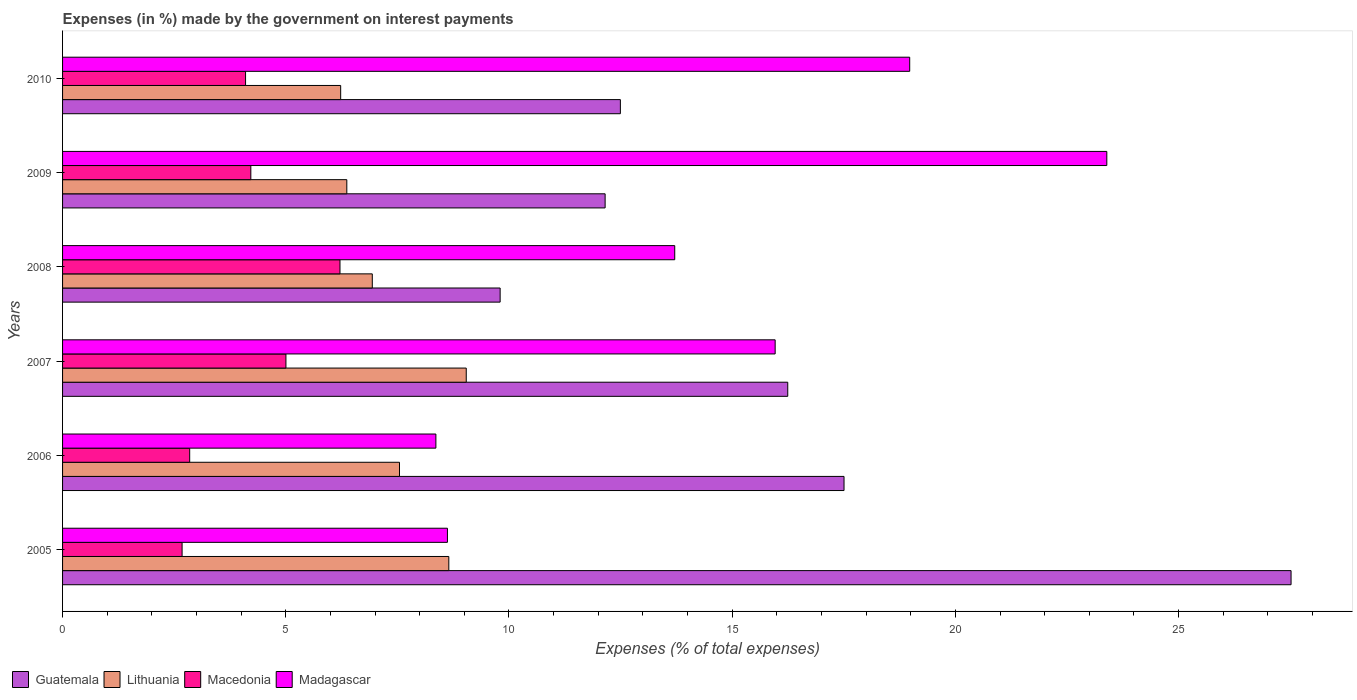How many different coloured bars are there?
Your answer should be compact. 4. How many groups of bars are there?
Provide a short and direct response. 6. How many bars are there on the 2nd tick from the bottom?
Provide a short and direct response. 4. What is the label of the 6th group of bars from the top?
Provide a short and direct response. 2005. What is the percentage of expenses made by the government on interest payments in Macedonia in 2005?
Give a very brief answer. 2.68. Across all years, what is the maximum percentage of expenses made by the government on interest payments in Guatemala?
Your answer should be very brief. 27.52. Across all years, what is the minimum percentage of expenses made by the government on interest payments in Macedonia?
Ensure brevity in your answer.  2.68. What is the total percentage of expenses made by the government on interest payments in Macedonia in the graph?
Your answer should be compact. 25.06. What is the difference between the percentage of expenses made by the government on interest payments in Lithuania in 2005 and that in 2009?
Provide a short and direct response. 2.28. What is the difference between the percentage of expenses made by the government on interest payments in Madagascar in 2010 and the percentage of expenses made by the government on interest payments in Lithuania in 2006?
Your answer should be compact. 11.43. What is the average percentage of expenses made by the government on interest payments in Lithuania per year?
Make the answer very short. 7.46. In the year 2006, what is the difference between the percentage of expenses made by the government on interest payments in Madagascar and percentage of expenses made by the government on interest payments in Lithuania?
Provide a succinct answer. 0.81. What is the ratio of the percentage of expenses made by the government on interest payments in Madagascar in 2007 to that in 2008?
Give a very brief answer. 1.16. What is the difference between the highest and the second highest percentage of expenses made by the government on interest payments in Guatemala?
Give a very brief answer. 10.01. What is the difference between the highest and the lowest percentage of expenses made by the government on interest payments in Madagascar?
Your answer should be compact. 15.03. In how many years, is the percentage of expenses made by the government on interest payments in Lithuania greater than the average percentage of expenses made by the government on interest payments in Lithuania taken over all years?
Make the answer very short. 3. What does the 1st bar from the top in 2009 represents?
Your answer should be compact. Madagascar. What does the 3rd bar from the bottom in 2009 represents?
Provide a short and direct response. Macedonia. Are all the bars in the graph horizontal?
Offer a very short reply. Yes. What is the difference between two consecutive major ticks on the X-axis?
Provide a short and direct response. 5. Are the values on the major ticks of X-axis written in scientific E-notation?
Offer a very short reply. No. Does the graph contain any zero values?
Give a very brief answer. No. How many legend labels are there?
Ensure brevity in your answer.  4. What is the title of the graph?
Offer a terse response. Expenses (in %) made by the government on interest payments. What is the label or title of the X-axis?
Offer a terse response. Expenses (% of total expenses). What is the Expenses (% of total expenses) in Guatemala in 2005?
Provide a succinct answer. 27.52. What is the Expenses (% of total expenses) of Lithuania in 2005?
Provide a succinct answer. 8.65. What is the Expenses (% of total expenses) of Macedonia in 2005?
Keep it short and to the point. 2.68. What is the Expenses (% of total expenses) of Madagascar in 2005?
Your answer should be compact. 8.62. What is the Expenses (% of total expenses) of Guatemala in 2006?
Your answer should be very brief. 17.51. What is the Expenses (% of total expenses) of Lithuania in 2006?
Ensure brevity in your answer.  7.55. What is the Expenses (% of total expenses) of Macedonia in 2006?
Offer a very short reply. 2.85. What is the Expenses (% of total expenses) in Madagascar in 2006?
Keep it short and to the point. 8.36. What is the Expenses (% of total expenses) in Guatemala in 2007?
Provide a succinct answer. 16.24. What is the Expenses (% of total expenses) of Lithuania in 2007?
Keep it short and to the point. 9.04. What is the Expenses (% of total expenses) of Macedonia in 2007?
Keep it short and to the point. 5. What is the Expenses (% of total expenses) in Madagascar in 2007?
Provide a short and direct response. 15.96. What is the Expenses (% of total expenses) of Guatemala in 2008?
Your answer should be compact. 9.8. What is the Expenses (% of total expenses) of Lithuania in 2008?
Offer a very short reply. 6.94. What is the Expenses (% of total expenses) of Macedonia in 2008?
Make the answer very short. 6.21. What is the Expenses (% of total expenses) in Madagascar in 2008?
Your answer should be very brief. 13.71. What is the Expenses (% of total expenses) of Guatemala in 2009?
Offer a very short reply. 12.15. What is the Expenses (% of total expenses) in Lithuania in 2009?
Provide a succinct answer. 6.37. What is the Expenses (% of total expenses) in Macedonia in 2009?
Your answer should be very brief. 4.22. What is the Expenses (% of total expenses) in Madagascar in 2009?
Offer a very short reply. 23.39. What is the Expenses (% of total expenses) of Guatemala in 2010?
Keep it short and to the point. 12.5. What is the Expenses (% of total expenses) in Lithuania in 2010?
Ensure brevity in your answer.  6.23. What is the Expenses (% of total expenses) in Macedonia in 2010?
Ensure brevity in your answer.  4.1. What is the Expenses (% of total expenses) of Madagascar in 2010?
Give a very brief answer. 18.98. Across all years, what is the maximum Expenses (% of total expenses) of Guatemala?
Ensure brevity in your answer.  27.52. Across all years, what is the maximum Expenses (% of total expenses) of Lithuania?
Offer a very short reply. 9.04. Across all years, what is the maximum Expenses (% of total expenses) in Macedonia?
Provide a short and direct response. 6.21. Across all years, what is the maximum Expenses (% of total expenses) in Madagascar?
Give a very brief answer. 23.39. Across all years, what is the minimum Expenses (% of total expenses) in Guatemala?
Offer a terse response. 9.8. Across all years, what is the minimum Expenses (% of total expenses) in Lithuania?
Offer a terse response. 6.23. Across all years, what is the minimum Expenses (% of total expenses) of Macedonia?
Make the answer very short. 2.68. Across all years, what is the minimum Expenses (% of total expenses) of Madagascar?
Your answer should be compact. 8.36. What is the total Expenses (% of total expenses) of Guatemala in the graph?
Ensure brevity in your answer.  95.72. What is the total Expenses (% of total expenses) in Lithuania in the graph?
Offer a terse response. 44.78. What is the total Expenses (% of total expenses) of Macedonia in the graph?
Provide a short and direct response. 25.06. What is the total Expenses (% of total expenses) in Madagascar in the graph?
Ensure brevity in your answer.  89.03. What is the difference between the Expenses (% of total expenses) of Guatemala in 2005 and that in 2006?
Make the answer very short. 10.01. What is the difference between the Expenses (% of total expenses) in Lithuania in 2005 and that in 2006?
Provide a short and direct response. 1.1. What is the difference between the Expenses (% of total expenses) of Macedonia in 2005 and that in 2006?
Keep it short and to the point. -0.17. What is the difference between the Expenses (% of total expenses) of Madagascar in 2005 and that in 2006?
Offer a very short reply. 0.26. What is the difference between the Expenses (% of total expenses) in Guatemala in 2005 and that in 2007?
Your answer should be very brief. 11.27. What is the difference between the Expenses (% of total expenses) in Lithuania in 2005 and that in 2007?
Provide a short and direct response. -0.39. What is the difference between the Expenses (% of total expenses) of Macedonia in 2005 and that in 2007?
Offer a terse response. -2.33. What is the difference between the Expenses (% of total expenses) in Madagascar in 2005 and that in 2007?
Your response must be concise. -7.34. What is the difference between the Expenses (% of total expenses) of Guatemala in 2005 and that in 2008?
Provide a succinct answer. 17.72. What is the difference between the Expenses (% of total expenses) in Lithuania in 2005 and that in 2008?
Keep it short and to the point. 1.71. What is the difference between the Expenses (% of total expenses) in Macedonia in 2005 and that in 2008?
Make the answer very short. -3.54. What is the difference between the Expenses (% of total expenses) in Madagascar in 2005 and that in 2008?
Provide a short and direct response. -5.09. What is the difference between the Expenses (% of total expenses) of Guatemala in 2005 and that in 2009?
Provide a succinct answer. 15.37. What is the difference between the Expenses (% of total expenses) in Lithuania in 2005 and that in 2009?
Provide a short and direct response. 2.28. What is the difference between the Expenses (% of total expenses) in Macedonia in 2005 and that in 2009?
Ensure brevity in your answer.  -1.54. What is the difference between the Expenses (% of total expenses) in Madagascar in 2005 and that in 2009?
Offer a terse response. -14.77. What is the difference between the Expenses (% of total expenses) of Guatemala in 2005 and that in 2010?
Your answer should be compact. 15.02. What is the difference between the Expenses (% of total expenses) of Lithuania in 2005 and that in 2010?
Your answer should be very brief. 2.42. What is the difference between the Expenses (% of total expenses) in Macedonia in 2005 and that in 2010?
Give a very brief answer. -1.42. What is the difference between the Expenses (% of total expenses) of Madagascar in 2005 and that in 2010?
Ensure brevity in your answer.  -10.36. What is the difference between the Expenses (% of total expenses) of Guatemala in 2006 and that in 2007?
Your response must be concise. 1.26. What is the difference between the Expenses (% of total expenses) in Lithuania in 2006 and that in 2007?
Ensure brevity in your answer.  -1.5. What is the difference between the Expenses (% of total expenses) of Macedonia in 2006 and that in 2007?
Provide a succinct answer. -2.16. What is the difference between the Expenses (% of total expenses) in Madagascar in 2006 and that in 2007?
Your answer should be compact. -7.6. What is the difference between the Expenses (% of total expenses) of Guatemala in 2006 and that in 2008?
Your response must be concise. 7.7. What is the difference between the Expenses (% of total expenses) in Lithuania in 2006 and that in 2008?
Your answer should be compact. 0.61. What is the difference between the Expenses (% of total expenses) of Macedonia in 2006 and that in 2008?
Provide a short and direct response. -3.37. What is the difference between the Expenses (% of total expenses) in Madagascar in 2006 and that in 2008?
Keep it short and to the point. -5.35. What is the difference between the Expenses (% of total expenses) in Guatemala in 2006 and that in 2009?
Give a very brief answer. 5.35. What is the difference between the Expenses (% of total expenses) in Lithuania in 2006 and that in 2009?
Give a very brief answer. 1.18. What is the difference between the Expenses (% of total expenses) of Macedonia in 2006 and that in 2009?
Your response must be concise. -1.37. What is the difference between the Expenses (% of total expenses) in Madagascar in 2006 and that in 2009?
Provide a short and direct response. -15.03. What is the difference between the Expenses (% of total expenses) in Guatemala in 2006 and that in 2010?
Make the answer very short. 5.01. What is the difference between the Expenses (% of total expenses) of Lithuania in 2006 and that in 2010?
Your answer should be compact. 1.32. What is the difference between the Expenses (% of total expenses) of Macedonia in 2006 and that in 2010?
Give a very brief answer. -1.25. What is the difference between the Expenses (% of total expenses) of Madagascar in 2006 and that in 2010?
Your response must be concise. -10.61. What is the difference between the Expenses (% of total expenses) in Guatemala in 2007 and that in 2008?
Offer a very short reply. 6.44. What is the difference between the Expenses (% of total expenses) of Lithuania in 2007 and that in 2008?
Give a very brief answer. 2.1. What is the difference between the Expenses (% of total expenses) of Macedonia in 2007 and that in 2008?
Give a very brief answer. -1.21. What is the difference between the Expenses (% of total expenses) of Madagascar in 2007 and that in 2008?
Provide a short and direct response. 2.25. What is the difference between the Expenses (% of total expenses) of Guatemala in 2007 and that in 2009?
Your answer should be very brief. 4.09. What is the difference between the Expenses (% of total expenses) in Lithuania in 2007 and that in 2009?
Provide a short and direct response. 2.68. What is the difference between the Expenses (% of total expenses) in Macedonia in 2007 and that in 2009?
Your answer should be very brief. 0.79. What is the difference between the Expenses (% of total expenses) of Madagascar in 2007 and that in 2009?
Ensure brevity in your answer.  -7.43. What is the difference between the Expenses (% of total expenses) in Guatemala in 2007 and that in 2010?
Offer a terse response. 3.75. What is the difference between the Expenses (% of total expenses) of Lithuania in 2007 and that in 2010?
Your answer should be very brief. 2.81. What is the difference between the Expenses (% of total expenses) of Macedonia in 2007 and that in 2010?
Your response must be concise. 0.9. What is the difference between the Expenses (% of total expenses) of Madagascar in 2007 and that in 2010?
Your response must be concise. -3.01. What is the difference between the Expenses (% of total expenses) of Guatemala in 2008 and that in 2009?
Provide a short and direct response. -2.35. What is the difference between the Expenses (% of total expenses) of Lithuania in 2008 and that in 2009?
Make the answer very short. 0.57. What is the difference between the Expenses (% of total expenses) in Macedonia in 2008 and that in 2009?
Your answer should be very brief. 2. What is the difference between the Expenses (% of total expenses) in Madagascar in 2008 and that in 2009?
Ensure brevity in your answer.  -9.68. What is the difference between the Expenses (% of total expenses) of Guatemala in 2008 and that in 2010?
Your response must be concise. -2.69. What is the difference between the Expenses (% of total expenses) of Lithuania in 2008 and that in 2010?
Your answer should be compact. 0.71. What is the difference between the Expenses (% of total expenses) of Macedonia in 2008 and that in 2010?
Offer a very short reply. 2.12. What is the difference between the Expenses (% of total expenses) in Madagascar in 2008 and that in 2010?
Offer a very short reply. -5.26. What is the difference between the Expenses (% of total expenses) of Guatemala in 2009 and that in 2010?
Provide a succinct answer. -0.34. What is the difference between the Expenses (% of total expenses) of Lithuania in 2009 and that in 2010?
Provide a succinct answer. 0.14. What is the difference between the Expenses (% of total expenses) in Macedonia in 2009 and that in 2010?
Provide a short and direct response. 0.12. What is the difference between the Expenses (% of total expenses) of Madagascar in 2009 and that in 2010?
Offer a very short reply. 4.42. What is the difference between the Expenses (% of total expenses) of Guatemala in 2005 and the Expenses (% of total expenses) of Lithuania in 2006?
Your answer should be compact. 19.97. What is the difference between the Expenses (% of total expenses) of Guatemala in 2005 and the Expenses (% of total expenses) of Macedonia in 2006?
Make the answer very short. 24.67. What is the difference between the Expenses (% of total expenses) in Guatemala in 2005 and the Expenses (% of total expenses) in Madagascar in 2006?
Your response must be concise. 19.16. What is the difference between the Expenses (% of total expenses) in Lithuania in 2005 and the Expenses (% of total expenses) in Macedonia in 2006?
Provide a short and direct response. 5.8. What is the difference between the Expenses (% of total expenses) in Lithuania in 2005 and the Expenses (% of total expenses) in Madagascar in 2006?
Provide a succinct answer. 0.29. What is the difference between the Expenses (% of total expenses) of Macedonia in 2005 and the Expenses (% of total expenses) of Madagascar in 2006?
Ensure brevity in your answer.  -5.69. What is the difference between the Expenses (% of total expenses) in Guatemala in 2005 and the Expenses (% of total expenses) in Lithuania in 2007?
Give a very brief answer. 18.48. What is the difference between the Expenses (% of total expenses) in Guatemala in 2005 and the Expenses (% of total expenses) in Macedonia in 2007?
Keep it short and to the point. 22.52. What is the difference between the Expenses (% of total expenses) in Guatemala in 2005 and the Expenses (% of total expenses) in Madagascar in 2007?
Keep it short and to the point. 11.56. What is the difference between the Expenses (% of total expenses) of Lithuania in 2005 and the Expenses (% of total expenses) of Macedonia in 2007?
Your answer should be very brief. 3.65. What is the difference between the Expenses (% of total expenses) of Lithuania in 2005 and the Expenses (% of total expenses) of Madagascar in 2007?
Your response must be concise. -7.31. What is the difference between the Expenses (% of total expenses) in Macedonia in 2005 and the Expenses (% of total expenses) in Madagascar in 2007?
Keep it short and to the point. -13.29. What is the difference between the Expenses (% of total expenses) in Guatemala in 2005 and the Expenses (% of total expenses) in Lithuania in 2008?
Provide a succinct answer. 20.58. What is the difference between the Expenses (% of total expenses) in Guatemala in 2005 and the Expenses (% of total expenses) in Macedonia in 2008?
Your answer should be very brief. 21.3. What is the difference between the Expenses (% of total expenses) of Guatemala in 2005 and the Expenses (% of total expenses) of Madagascar in 2008?
Give a very brief answer. 13.81. What is the difference between the Expenses (% of total expenses) of Lithuania in 2005 and the Expenses (% of total expenses) of Macedonia in 2008?
Provide a short and direct response. 2.44. What is the difference between the Expenses (% of total expenses) of Lithuania in 2005 and the Expenses (% of total expenses) of Madagascar in 2008?
Provide a succinct answer. -5.06. What is the difference between the Expenses (% of total expenses) of Macedonia in 2005 and the Expenses (% of total expenses) of Madagascar in 2008?
Your response must be concise. -11.04. What is the difference between the Expenses (% of total expenses) of Guatemala in 2005 and the Expenses (% of total expenses) of Lithuania in 2009?
Provide a short and direct response. 21.15. What is the difference between the Expenses (% of total expenses) of Guatemala in 2005 and the Expenses (% of total expenses) of Macedonia in 2009?
Your answer should be very brief. 23.3. What is the difference between the Expenses (% of total expenses) of Guatemala in 2005 and the Expenses (% of total expenses) of Madagascar in 2009?
Make the answer very short. 4.13. What is the difference between the Expenses (% of total expenses) in Lithuania in 2005 and the Expenses (% of total expenses) in Macedonia in 2009?
Provide a succinct answer. 4.43. What is the difference between the Expenses (% of total expenses) of Lithuania in 2005 and the Expenses (% of total expenses) of Madagascar in 2009?
Offer a very short reply. -14.74. What is the difference between the Expenses (% of total expenses) of Macedonia in 2005 and the Expenses (% of total expenses) of Madagascar in 2009?
Make the answer very short. -20.71. What is the difference between the Expenses (% of total expenses) of Guatemala in 2005 and the Expenses (% of total expenses) of Lithuania in 2010?
Give a very brief answer. 21.29. What is the difference between the Expenses (% of total expenses) in Guatemala in 2005 and the Expenses (% of total expenses) in Macedonia in 2010?
Your answer should be compact. 23.42. What is the difference between the Expenses (% of total expenses) of Guatemala in 2005 and the Expenses (% of total expenses) of Madagascar in 2010?
Make the answer very short. 8.54. What is the difference between the Expenses (% of total expenses) in Lithuania in 2005 and the Expenses (% of total expenses) in Macedonia in 2010?
Offer a very short reply. 4.55. What is the difference between the Expenses (% of total expenses) in Lithuania in 2005 and the Expenses (% of total expenses) in Madagascar in 2010?
Provide a short and direct response. -10.32. What is the difference between the Expenses (% of total expenses) of Macedonia in 2005 and the Expenses (% of total expenses) of Madagascar in 2010?
Ensure brevity in your answer.  -16.3. What is the difference between the Expenses (% of total expenses) in Guatemala in 2006 and the Expenses (% of total expenses) in Lithuania in 2007?
Provide a succinct answer. 8.46. What is the difference between the Expenses (% of total expenses) of Guatemala in 2006 and the Expenses (% of total expenses) of Macedonia in 2007?
Offer a terse response. 12.5. What is the difference between the Expenses (% of total expenses) of Guatemala in 2006 and the Expenses (% of total expenses) of Madagascar in 2007?
Provide a short and direct response. 1.54. What is the difference between the Expenses (% of total expenses) in Lithuania in 2006 and the Expenses (% of total expenses) in Macedonia in 2007?
Offer a terse response. 2.54. What is the difference between the Expenses (% of total expenses) of Lithuania in 2006 and the Expenses (% of total expenses) of Madagascar in 2007?
Provide a succinct answer. -8.41. What is the difference between the Expenses (% of total expenses) in Macedonia in 2006 and the Expenses (% of total expenses) in Madagascar in 2007?
Provide a short and direct response. -13.11. What is the difference between the Expenses (% of total expenses) of Guatemala in 2006 and the Expenses (% of total expenses) of Lithuania in 2008?
Ensure brevity in your answer.  10.57. What is the difference between the Expenses (% of total expenses) of Guatemala in 2006 and the Expenses (% of total expenses) of Macedonia in 2008?
Keep it short and to the point. 11.29. What is the difference between the Expenses (% of total expenses) in Guatemala in 2006 and the Expenses (% of total expenses) in Madagascar in 2008?
Ensure brevity in your answer.  3.79. What is the difference between the Expenses (% of total expenses) in Lithuania in 2006 and the Expenses (% of total expenses) in Macedonia in 2008?
Your answer should be compact. 1.33. What is the difference between the Expenses (% of total expenses) in Lithuania in 2006 and the Expenses (% of total expenses) in Madagascar in 2008?
Provide a succinct answer. -6.17. What is the difference between the Expenses (% of total expenses) of Macedonia in 2006 and the Expenses (% of total expenses) of Madagascar in 2008?
Your answer should be compact. -10.87. What is the difference between the Expenses (% of total expenses) in Guatemala in 2006 and the Expenses (% of total expenses) in Lithuania in 2009?
Your response must be concise. 11.14. What is the difference between the Expenses (% of total expenses) of Guatemala in 2006 and the Expenses (% of total expenses) of Macedonia in 2009?
Offer a very short reply. 13.29. What is the difference between the Expenses (% of total expenses) of Guatemala in 2006 and the Expenses (% of total expenses) of Madagascar in 2009?
Make the answer very short. -5.89. What is the difference between the Expenses (% of total expenses) of Lithuania in 2006 and the Expenses (% of total expenses) of Macedonia in 2009?
Ensure brevity in your answer.  3.33. What is the difference between the Expenses (% of total expenses) in Lithuania in 2006 and the Expenses (% of total expenses) in Madagascar in 2009?
Your answer should be compact. -15.84. What is the difference between the Expenses (% of total expenses) in Macedonia in 2006 and the Expenses (% of total expenses) in Madagascar in 2009?
Make the answer very short. -20.54. What is the difference between the Expenses (% of total expenses) of Guatemala in 2006 and the Expenses (% of total expenses) of Lithuania in 2010?
Provide a succinct answer. 11.28. What is the difference between the Expenses (% of total expenses) in Guatemala in 2006 and the Expenses (% of total expenses) in Macedonia in 2010?
Make the answer very short. 13.41. What is the difference between the Expenses (% of total expenses) of Guatemala in 2006 and the Expenses (% of total expenses) of Madagascar in 2010?
Make the answer very short. -1.47. What is the difference between the Expenses (% of total expenses) in Lithuania in 2006 and the Expenses (% of total expenses) in Macedonia in 2010?
Your answer should be compact. 3.45. What is the difference between the Expenses (% of total expenses) of Lithuania in 2006 and the Expenses (% of total expenses) of Madagascar in 2010?
Provide a succinct answer. -11.43. What is the difference between the Expenses (% of total expenses) of Macedonia in 2006 and the Expenses (% of total expenses) of Madagascar in 2010?
Your answer should be very brief. -16.13. What is the difference between the Expenses (% of total expenses) of Guatemala in 2007 and the Expenses (% of total expenses) of Lithuania in 2008?
Your answer should be very brief. 9.31. What is the difference between the Expenses (% of total expenses) in Guatemala in 2007 and the Expenses (% of total expenses) in Macedonia in 2008?
Offer a very short reply. 10.03. What is the difference between the Expenses (% of total expenses) in Guatemala in 2007 and the Expenses (% of total expenses) in Madagascar in 2008?
Keep it short and to the point. 2.53. What is the difference between the Expenses (% of total expenses) of Lithuania in 2007 and the Expenses (% of total expenses) of Macedonia in 2008?
Your answer should be compact. 2.83. What is the difference between the Expenses (% of total expenses) in Lithuania in 2007 and the Expenses (% of total expenses) in Madagascar in 2008?
Offer a terse response. -4.67. What is the difference between the Expenses (% of total expenses) of Macedonia in 2007 and the Expenses (% of total expenses) of Madagascar in 2008?
Make the answer very short. -8.71. What is the difference between the Expenses (% of total expenses) of Guatemala in 2007 and the Expenses (% of total expenses) of Lithuania in 2009?
Give a very brief answer. 9.88. What is the difference between the Expenses (% of total expenses) in Guatemala in 2007 and the Expenses (% of total expenses) in Macedonia in 2009?
Your response must be concise. 12.03. What is the difference between the Expenses (% of total expenses) in Guatemala in 2007 and the Expenses (% of total expenses) in Madagascar in 2009?
Your response must be concise. -7.15. What is the difference between the Expenses (% of total expenses) in Lithuania in 2007 and the Expenses (% of total expenses) in Macedonia in 2009?
Provide a short and direct response. 4.83. What is the difference between the Expenses (% of total expenses) in Lithuania in 2007 and the Expenses (% of total expenses) in Madagascar in 2009?
Provide a short and direct response. -14.35. What is the difference between the Expenses (% of total expenses) of Macedonia in 2007 and the Expenses (% of total expenses) of Madagascar in 2009?
Provide a short and direct response. -18.39. What is the difference between the Expenses (% of total expenses) of Guatemala in 2007 and the Expenses (% of total expenses) of Lithuania in 2010?
Provide a succinct answer. 10.01. What is the difference between the Expenses (% of total expenses) of Guatemala in 2007 and the Expenses (% of total expenses) of Macedonia in 2010?
Provide a succinct answer. 12.15. What is the difference between the Expenses (% of total expenses) in Guatemala in 2007 and the Expenses (% of total expenses) in Madagascar in 2010?
Make the answer very short. -2.73. What is the difference between the Expenses (% of total expenses) in Lithuania in 2007 and the Expenses (% of total expenses) in Macedonia in 2010?
Offer a very short reply. 4.94. What is the difference between the Expenses (% of total expenses) of Lithuania in 2007 and the Expenses (% of total expenses) of Madagascar in 2010?
Your response must be concise. -9.93. What is the difference between the Expenses (% of total expenses) of Macedonia in 2007 and the Expenses (% of total expenses) of Madagascar in 2010?
Provide a short and direct response. -13.97. What is the difference between the Expenses (% of total expenses) in Guatemala in 2008 and the Expenses (% of total expenses) in Lithuania in 2009?
Keep it short and to the point. 3.43. What is the difference between the Expenses (% of total expenses) of Guatemala in 2008 and the Expenses (% of total expenses) of Macedonia in 2009?
Offer a very short reply. 5.58. What is the difference between the Expenses (% of total expenses) of Guatemala in 2008 and the Expenses (% of total expenses) of Madagascar in 2009?
Make the answer very short. -13.59. What is the difference between the Expenses (% of total expenses) of Lithuania in 2008 and the Expenses (% of total expenses) of Macedonia in 2009?
Your answer should be compact. 2.72. What is the difference between the Expenses (% of total expenses) in Lithuania in 2008 and the Expenses (% of total expenses) in Madagascar in 2009?
Ensure brevity in your answer.  -16.45. What is the difference between the Expenses (% of total expenses) of Macedonia in 2008 and the Expenses (% of total expenses) of Madagascar in 2009?
Make the answer very short. -17.18. What is the difference between the Expenses (% of total expenses) of Guatemala in 2008 and the Expenses (% of total expenses) of Lithuania in 2010?
Keep it short and to the point. 3.57. What is the difference between the Expenses (% of total expenses) of Guatemala in 2008 and the Expenses (% of total expenses) of Macedonia in 2010?
Your answer should be compact. 5.7. What is the difference between the Expenses (% of total expenses) of Guatemala in 2008 and the Expenses (% of total expenses) of Madagascar in 2010?
Give a very brief answer. -9.17. What is the difference between the Expenses (% of total expenses) in Lithuania in 2008 and the Expenses (% of total expenses) in Macedonia in 2010?
Keep it short and to the point. 2.84. What is the difference between the Expenses (% of total expenses) in Lithuania in 2008 and the Expenses (% of total expenses) in Madagascar in 2010?
Make the answer very short. -12.04. What is the difference between the Expenses (% of total expenses) of Macedonia in 2008 and the Expenses (% of total expenses) of Madagascar in 2010?
Your response must be concise. -12.76. What is the difference between the Expenses (% of total expenses) of Guatemala in 2009 and the Expenses (% of total expenses) of Lithuania in 2010?
Offer a very short reply. 5.92. What is the difference between the Expenses (% of total expenses) of Guatemala in 2009 and the Expenses (% of total expenses) of Macedonia in 2010?
Provide a succinct answer. 8.05. What is the difference between the Expenses (% of total expenses) of Guatemala in 2009 and the Expenses (% of total expenses) of Madagascar in 2010?
Give a very brief answer. -6.82. What is the difference between the Expenses (% of total expenses) in Lithuania in 2009 and the Expenses (% of total expenses) in Macedonia in 2010?
Keep it short and to the point. 2.27. What is the difference between the Expenses (% of total expenses) of Lithuania in 2009 and the Expenses (% of total expenses) of Madagascar in 2010?
Give a very brief answer. -12.61. What is the difference between the Expenses (% of total expenses) in Macedonia in 2009 and the Expenses (% of total expenses) in Madagascar in 2010?
Your answer should be compact. -14.76. What is the average Expenses (% of total expenses) in Guatemala per year?
Provide a short and direct response. 15.95. What is the average Expenses (% of total expenses) in Lithuania per year?
Your answer should be compact. 7.46. What is the average Expenses (% of total expenses) in Macedonia per year?
Make the answer very short. 4.18. What is the average Expenses (% of total expenses) in Madagascar per year?
Provide a short and direct response. 14.84. In the year 2005, what is the difference between the Expenses (% of total expenses) of Guatemala and Expenses (% of total expenses) of Lithuania?
Your answer should be compact. 18.87. In the year 2005, what is the difference between the Expenses (% of total expenses) of Guatemala and Expenses (% of total expenses) of Macedonia?
Provide a short and direct response. 24.84. In the year 2005, what is the difference between the Expenses (% of total expenses) in Guatemala and Expenses (% of total expenses) in Madagascar?
Give a very brief answer. 18.9. In the year 2005, what is the difference between the Expenses (% of total expenses) of Lithuania and Expenses (% of total expenses) of Macedonia?
Offer a terse response. 5.97. In the year 2005, what is the difference between the Expenses (% of total expenses) of Lithuania and Expenses (% of total expenses) of Madagascar?
Provide a short and direct response. 0.03. In the year 2005, what is the difference between the Expenses (% of total expenses) of Macedonia and Expenses (% of total expenses) of Madagascar?
Ensure brevity in your answer.  -5.94. In the year 2006, what is the difference between the Expenses (% of total expenses) of Guatemala and Expenses (% of total expenses) of Lithuania?
Offer a very short reply. 9.96. In the year 2006, what is the difference between the Expenses (% of total expenses) in Guatemala and Expenses (% of total expenses) in Macedonia?
Provide a succinct answer. 14.66. In the year 2006, what is the difference between the Expenses (% of total expenses) in Guatemala and Expenses (% of total expenses) in Madagascar?
Give a very brief answer. 9.14. In the year 2006, what is the difference between the Expenses (% of total expenses) of Lithuania and Expenses (% of total expenses) of Macedonia?
Provide a short and direct response. 4.7. In the year 2006, what is the difference between the Expenses (% of total expenses) of Lithuania and Expenses (% of total expenses) of Madagascar?
Provide a succinct answer. -0.81. In the year 2006, what is the difference between the Expenses (% of total expenses) of Macedonia and Expenses (% of total expenses) of Madagascar?
Your answer should be very brief. -5.51. In the year 2007, what is the difference between the Expenses (% of total expenses) in Guatemala and Expenses (% of total expenses) in Lithuania?
Provide a succinct answer. 7.2. In the year 2007, what is the difference between the Expenses (% of total expenses) of Guatemala and Expenses (% of total expenses) of Macedonia?
Keep it short and to the point. 11.24. In the year 2007, what is the difference between the Expenses (% of total expenses) of Guatemala and Expenses (% of total expenses) of Madagascar?
Your response must be concise. 0.28. In the year 2007, what is the difference between the Expenses (% of total expenses) in Lithuania and Expenses (% of total expenses) in Macedonia?
Your response must be concise. 4.04. In the year 2007, what is the difference between the Expenses (% of total expenses) of Lithuania and Expenses (% of total expenses) of Madagascar?
Give a very brief answer. -6.92. In the year 2007, what is the difference between the Expenses (% of total expenses) in Macedonia and Expenses (% of total expenses) in Madagascar?
Your answer should be very brief. -10.96. In the year 2008, what is the difference between the Expenses (% of total expenses) of Guatemala and Expenses (% of total expenses) of Lithuania?
Provide a succinct answer. 2.86. In the year 2008, what is the difference between the Expenses (% of total expenses) in Guatemala and Expenses (% of total expenses) in Macedonia?
Your response must be concise. 3.59. In the year 2008, what is the difference between the Expenses (% of total expenses) in Guatemala and Expenses (% of total expenses) in Madagascar?
Give a very brief answer. -3.91. In the year 2008, what is the difference between the Expenses (% of total expenses) in Lithuania and Expenses (% of total expenses) in Macedonia?
Your answer should be compact. 0.72. In the year 2008, what is the difference between the Expenses (% of total expenses) in Lithuania and Expenses (% of total expenses) in Madagascar?
Offer a very short reply. -6.78. In the year 2008, what is the difference between the Expenses (% of total expenses) in Macedonia and Expenses (% of total expenses) in Madagascar?
Provide a succinct answer. -7.5. In the year 2009, what is the difference between the Expenses (% of total expenses) of Guatemala and Expenses (% of total expenses) of Lithuania?
Keep it short and to the point. 5.79. In the year 2009, what is the difference between the Expenses (% of total expenses) in Guatemala and Expenses (% of total expenses) in Macedonia?
Keep it short and to the point. 7.94. In the year 2009, what is the difference between the Expenses (% of total expenses) in Guatemala and Expenses (% of total expenses) in Madagascar?
Offer a very short reply. -11.24. In the year 2009, what is the difference between the Expenses (% of total expenses) in Lithuania and Expenses (% of total expenses) in Macedonia?
Your answer should be compact. 2.15. In the year 2009, what is the difference between the Expenses (% of total expenses) in Lithuania and Expenses (% of total expenses) in Madagascar?
Keep it short and to the point. -17.02. In the year 2009, what is the difference between the Expenses (% of total expenses) of Macedonia and Expenses (% of total expenses) of Madagascar?
Offer a very short reply. -19.17. In the year 2010, what is the difference between the Expenses (% of total expenses) of Guatemala and Expenses (% of total expenses) of Lithuania?
Offer a terse response. 6.27. In the year 2010, what is the difference between the Expenses (% of total expenses) of Guatemala and Expenses (% of total expenses) of Macedonia?
Your answer should be very brief. 8.4. In the year 2010, what is the difference between the Expenses (% of total expenses) of Guatemala and Expenses (% of total expenses) of Madagascar?
Your response must be concise. -6.48. In the year 2010, what is the difference between the Expenses (% of total expenses) in Lithuania and Expenses (% of total expenses) in Macedonia?
Give a very brief answer. 2.13. In the year 2010, what is the difference between the Expenses (% of total expenses) of Lithuania and Expenses (% of total expenses) of Madagascar?
Offer a very short reply. -12.75. In the year 2010, what is the difference between the Expenses (% of total expenses) in Macedonia and Expenses (% of total expenses) in Madagascar?
Ensure brevity in your answer.  -14.88. What is the ratio of the Expenses (% of total expenses) in Guatemala in 2005 to that in 2006?
Give a very brief answer. 1.57. What is the ratio of the Expenses (% of total expenses) of Lithuania in 2005 to that in 2006?
Ensure brevity in your answer.  1.15. What is the ratio of the Expenses (% of total expenses) in Macedonia in 2005 to that in 2006?
Your response must be concise. 0.94. What is the ratio of the Expenses (% of total expenses) of Madagascar in 2005 to that in 2006?
Provide a short and direct response. 1.03. What is the ratio of the Expenses (% of total expenses) of Guatemala in 2005 to that in 2007?
Your answer should be very brief. 1.69. What is the ratio of the Expenses (% of total expenses) of Lithuania in 2005 to that in 2007?
Offer a very short reply. 0.96. What is the ratio of the Expenses (% of total expenses) in Macedonia in 2005 to that in 2007?
Ensure brevity in your answer.  0.54. What is the ratio of the Expenses (% of total expenses) of Madagascar in 2005 to that in 2007?
Ensure brevity in your answer.  0.54. What is the ratio of the Expenses (% of total expenses) in Guatemala in 2005 to that in 2008?
Provide a short and direct response. 2.81. What is the ratio of the Expenses (% of total expenses) in Lithuania in 2005 to that in 2008?
Your answer should be very brief. 1.25. What is the ratio of the Expenses (% of total expenses) in Macedonia in 2005 to that in 2008?
Ensure brevity in your answer.  0.43. What is the ratio of the Expenses (% of total expenses) in Madagascar in 2005 to that in 2008?
Your answer should be compact. 0.63. What is the ratio of the Expenses (% of total expenses) in Guatemala in 2005 to that in 2009?
Keep it short and to the point. 2.26. What is the ratio of the Expenses (% of total expenses) in Lithuania in 2005 to that in 2009?
Your answer should be very brief. 1.36. What is the ratio of the Expenses (% of total expenses) of Macedonia in 2005 to that in 2009?
Your response must be concise. 0.63. What is the ratio of the Expenses (% of total expenses) in Madagascar in 2005 to that in 2009?
Ensure brevity in your answer.  0.37. What is the ratio of the Expenses (% of total expenses) in Guatemala in 2005 to that in 2010?
Offer a very short reply. 2.2. What is the ratio of the Expenses (% of total expenses) of Lithuania in 2005 to that in 2010?
Provide a short and direct response. 1.39. What is the ratio of the Expenses (% of total expenses) in Macedonia in 2005 to that in 2010?
Offer a terse response. 0.65. What is the ratio of the Expenses (% of total expenses) of Madagascar in 2005 to that in 2010?
Your answer should be compact. 0.45. What is the ratio of the Expenses (% of total expenses) in Guatemala in 2006 to that in 2007?
Make the answer very short. 1.08. What is the ratio of the Expenses (% of total expenses) of Lithuania in 2006 to that in 2007?
Ensure brevity in your answer.  0.83. What is the ratio of the Expenses (% of total expenses) of Macedonia in 2006 to that in 2007?
Give a very brief answer. 0.57. What is the ratio of the Expenses (% of total expenses) in Madagascar in 2006 to that in 2007?
Provide a short and direct response. 0.52. What is the ratio of the Expenses (% of total expenses) of Guatemala in 2006 to that in 2008?
Give a very brief answer. 1.79. What is the ratio of the Expenses (% of total expenses) of Lithuania in 2006 to that in 2008?
Keep it short and to the point. 1.09. What is the ratio of the Expenses (% of total expenses) of Macedonia in 2006 to that in 2008?
Offer a very short reply. 0.46. What is the ratio of the Expenses (% of total expenses) of Madagascar in 2006 to that in 2008?
Your answer should be compact. 0.61. What is the ratio of the Expenses (% of total expenses) in Guatemala in 2006 to that in 2009?
Make the answer very short. 1.44. What is the ratio of the Expenses (% of total expenses) in Lithuania in 2006 to that in 2009?
Your answer should be very brief. 1.19. What is the ratio of the Expenses (% of total expenses) of Macedonia in 2006 to that in 2009?
Provide a short and direct response. 0.68. What is the ratio of the Expenses (% of total expenses) in Madagascar in 2006 to that in 2009?
Provide a succinct answer. 0.36. What is the ratio of the Expenses (% of total expenses) of Guatemala in 2006 to that in 2010?
Provide a succinct answer. 1.4. What is the ratio of the Expenses (% of total expenses) of Lithuania in 2006 to that in 2010?
Provide a short and direct response. 1.21. What is the ratio of the Expenses (% of total expenses) of Macedonia in 2006 to that in 2010?
Your answer should be compact. 0.69. What is the ratio of the Expenses (% of total expenses) in Madagascar in 2006 to that in 2010?
Provide a succinct answer. 0.44. What is the ratio of the Expenses (% of total expenses) in Guatemala in 2007 to that in 2008?
Offer a very short reply. 1.66. What is the ratio of the Expenses (% of total expenses) of Lithuania in 2007 to that in 2008?
Give a very brief answer. 1.3. What is the ratio of the Expenses (% of total expenses) of Macedonia in 2007 to that in 2008?
Offer a very short reply. 0.81. What is the ratio of the Expenses (% of total expenses) of Madagascar in 2007 to that in 2008?
Your answer should be compact. 1.16. What is the ratio of the Expenses (% of total expenses) in Guatemala in 2007 to that in 2009?
Your answer should be very brief. 1.34. What is the ratio of the Expenses (% of total expenses) in Lithuania in 2007 to that in 2009?
Make the answer very short. 1.42. What is the ratio of the Expenses (% of total expenses) of Macedonia in 2007 to that in 2009?
Your response must be concise. 1.19. What is the ratio of the Expenses (% of total expenses) of Madagascar in 2007 to that in 2009?
Your answer should be very brief. 0.68. What is the ratio of the Expenses (% of total expenses) in Guatemala in 2007 to that in 2010?
Offer a very short reply. 1.3. What is the ratio of the Expenses (% of total expenses) in Lithuania in 2007 to that in 2010?
Your answer should be compact. 1.45. What is the ratio of the Expenses (% of total expenses) in Macedonia in 2007 to that in 2010?
Your answer should be compact. 1.22. What is the ratio of the Expenses (% of total expenses) of Madagascar in 2007 to that in 2010?
Ensure brevity in your answer.  0.84. What is the ratio of the Expenses (% of total expenses) in Guatemala in 2008 to that in 2009?
Give a very brief answer. 0.81. What is the ratio of the Expenses (% of total expenses) of Lithuania in 2008 to that in 2009?
Make the answer very short. 1.09. What is the ratio of the Expenses (% of total expenses) of Macedonia in 2008 to that in 2009?
Your answer should be very brief. 1.47. What is the ratio of the Expenses (% of total expenses) of Madagascar in 2008 to that in 2009?
Ensure brevity in your answer.  0.59. What is the ratio of the Expenses (% of total expenses) in Guatemala in 2008 to that in 2010?
Your response must be concise. 0.78. What is the ratio of the Expenses (% of total expenses) of Lithuania in 2008 to that in 2010?
Provide a short and direct response. 1.11. What is the ratio of the Expenses (% of total expenses) in Macedonia in 2008 to that in 2010?
Provide a short and direct response. 1.52. What is the ratio of the Expenses (% of total expenses) in Madagascar in 2008 to that in 2010?
Your answer should be compact. 0.72. What is the ratio of the Expenses (% of total expenses) of Guatemala in 2009 to that in 2010?
Provide a short and direct response. 0.97. What is the ratio of the Expenses (% of total expenses) in Macedonia in 2009 to that in 2010?
Your answer should be compact. 1.03. What is the ratio of the Expenses (% of total expenses) of Madagascar in 2009 to that in 2010?
Give a very brief answer. 1.23. What is the difference between the highest and the second highest Expenses (% of total expenses) in Guatemala?
Offer a terse response. 10.01. What is the difference between the highest and the second highest Expenses (% of total expenses) in Lithuania?
Offer a terse response. 0.39. What is the difference between the highest and the second highest Expenses (% of total expenses) in Macedonia?
Offer a terse response. 1.21. What is the difference between the highest and the second highest Expenses (% of total expenses) in Madagascar?
Offer a terse response. 4.42. What is the difference between the highest and the lowest Expenses (% of total expenses) in Guatemala?
Ensure brevity in your answer.  17.72. What is the difference between the highest and the lowest Expenses (% of total expenses) of Lithuania?
Ensure brevity in your answer.  2.81. What is the difference between the highest and the lowest Expenses (% of total expenses) of Macedonia?
Offer a terse response. 3.54. What is the difference between the highest and the lowest Expenses (% of total expenses) in Madagascar?
Provide a succinct answer. 15.03. 